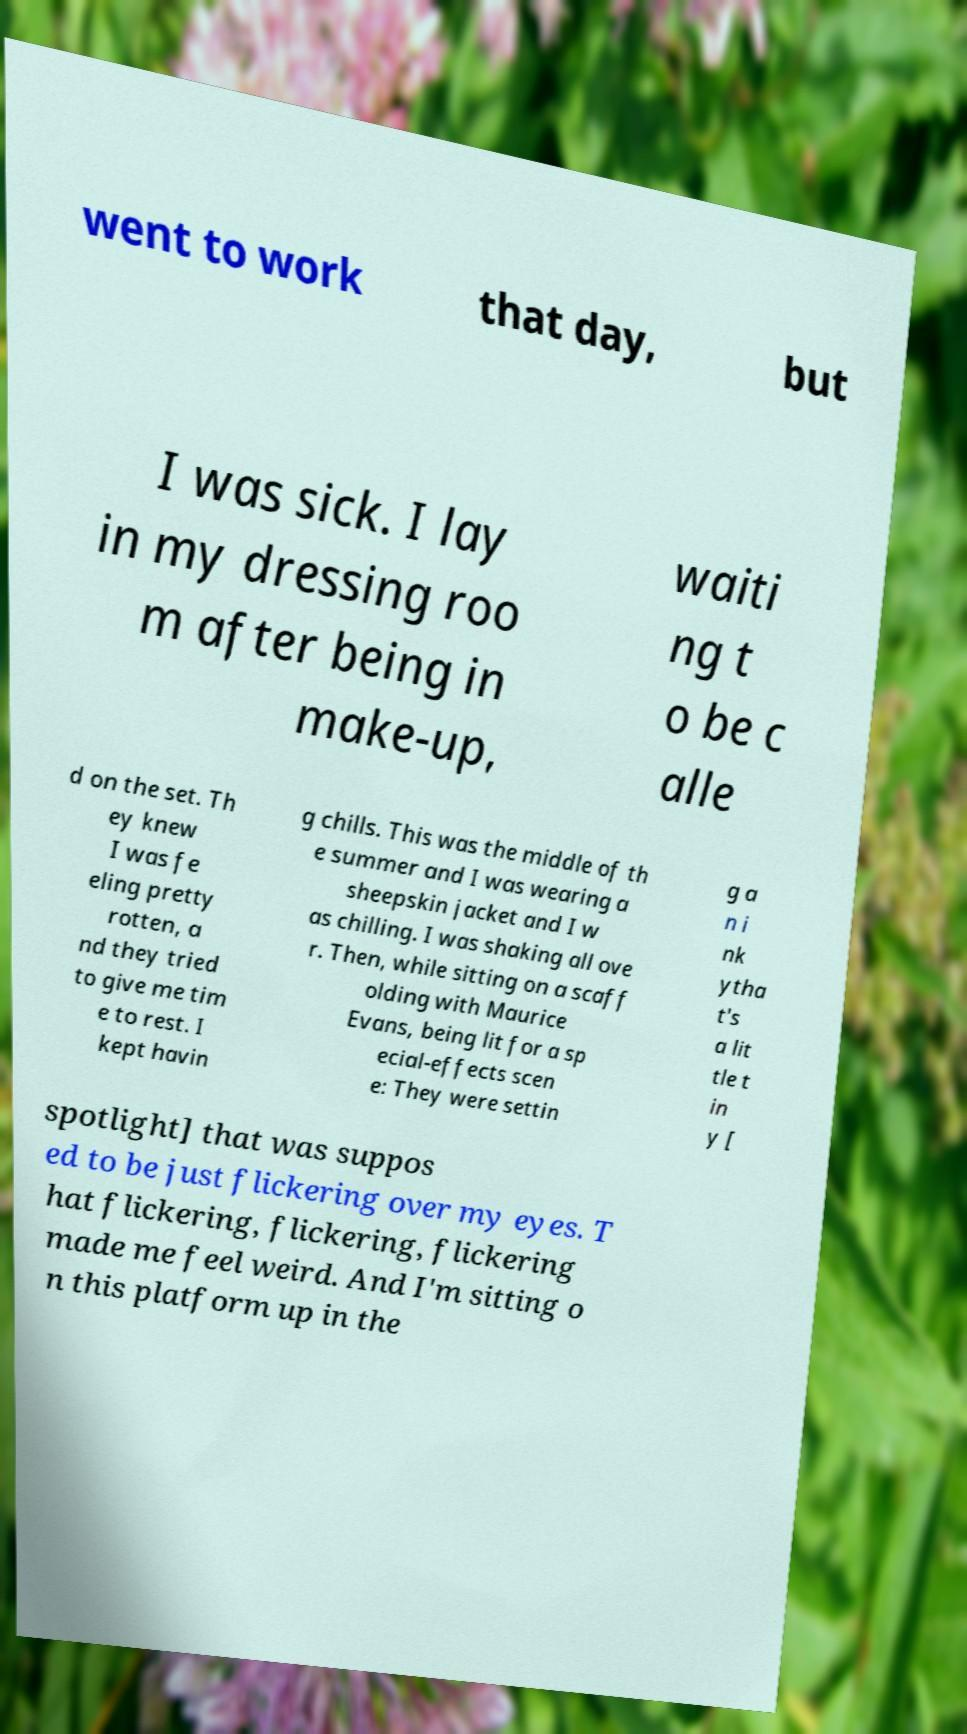For documentation purposes, I need the text within this image transcribed. Could you provide that? went to work that day, but I was sick. I lay in my dressing roo m after being in make-up, waiti ng t o be c alle d on the set. Th ey knew I was fe eling pretty rotten, a nd they tried to give me tim e to rest. I kept havin g chills. This was the middle of th e summer and I was wearing a sheepskin jacket and I w as chilling. I was shaking all ove r. Then, while sitting on a scaff olding with Maurice Evans, being lit for a sp ecial-effects scen e: They were settin g a n i nk ytha t's a lit tle t in y [ spotlight] that was suppos ed to be just flickering over my eyes. T hat flickering, flickering, flickering made me feel weird. And I'm sitting o n this platform up in the 